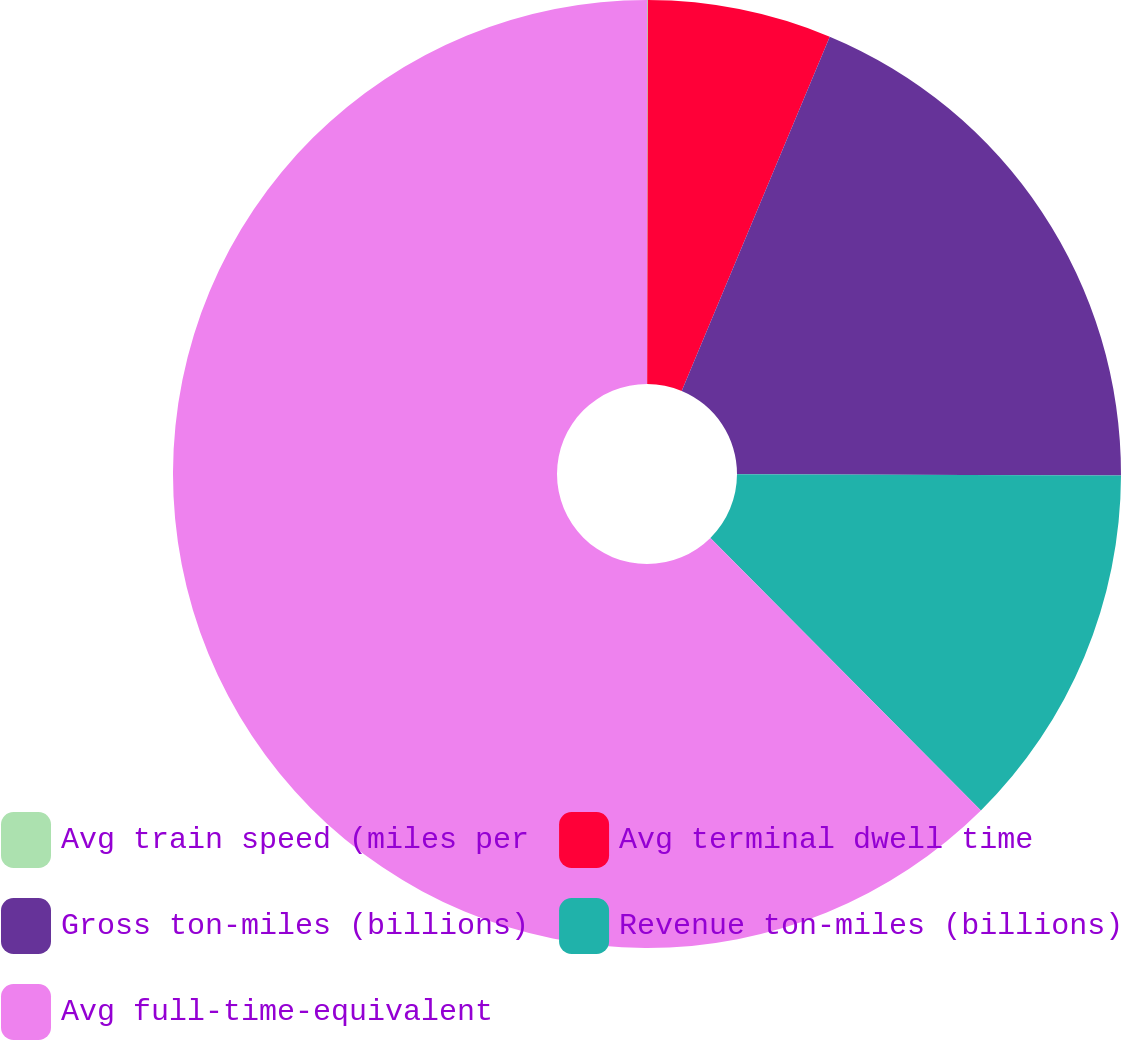<chart> <loc_0><loc_0><loc_500><loc_500><pie_chart><fcel>Avg train speed (miles per<fcel>Avg terminal dwell time<fcel>Gross ton-miles (billions)<fcel>Revenue ton-miles (billions)<fcel>Avg full-time-equivalent<nl><fcel>0.03%<fcel>6.27%<fcel>18.75%<fcel>12.51%<fcel>62.44%<nl></chart> 